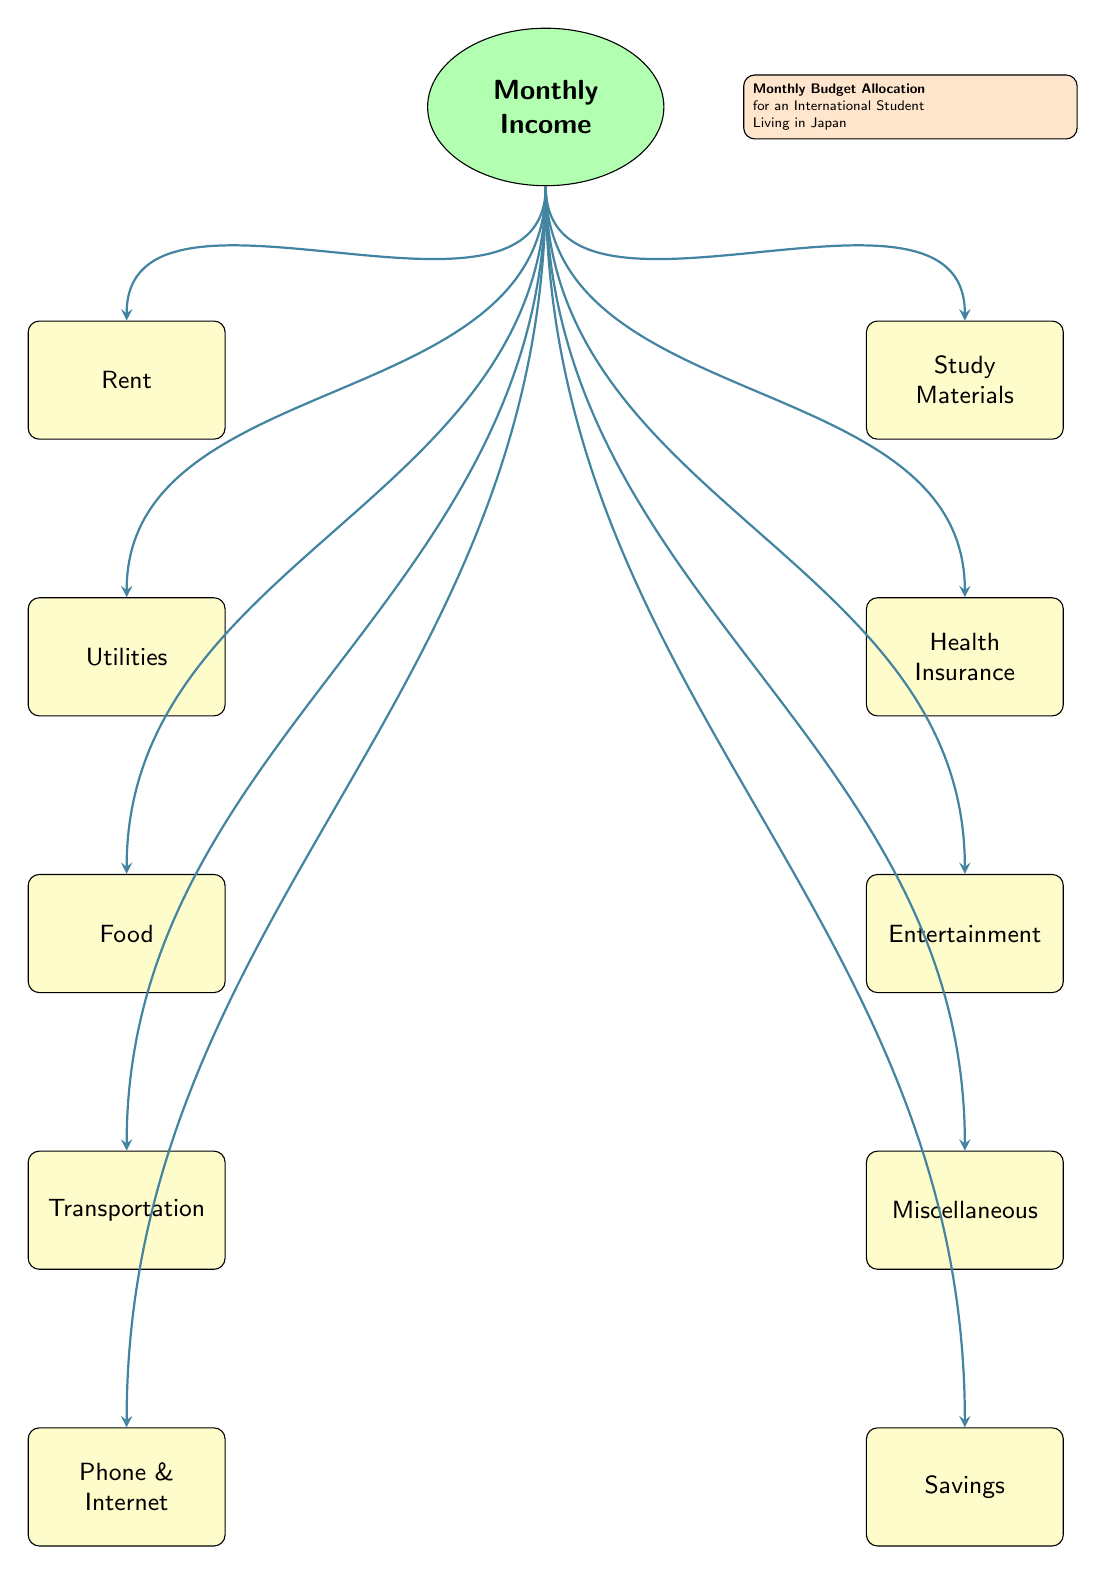What is the first expense node connected to the income? The diagram indicates the first expense directly under the income node, which is rent. This can be identified by observing the direction of the arrows flowing from the income node to each expense node vertically.
Answer: Rent How many total expense nodes are there? By counting all the individual expense nodes listed below the income node, we find there are ten expense categories: Rent, Utilities, Food, Transportation, Phone & Internet, Study Materials, Health Insurance, Entertainment, Miscellaneous, and Savings. Therefore, the total amount of expense nodes is ten.
Answer: 10 What type of shape is used to represent income? The income node is visually represented as an ellipse. We can identify this by looking at the shape classification provided in the diagram's code, where it defines income with a specific drawing style that forms an ellipse.
Answer: Ellipse Which expense node is closest to the income in the top left section? The nearest expense node to the income in the top left section is Rent. We determine this by noting which node appears immediately below the income node on the left side.
Answer: Rent What is the last expense node listed in the right section? The last expense node listed in the right section is Savings. To find this, we follow the sequence of nodes downward in the right area, and Savings appears at the bottom-most position.
Answer: Savings Which two expense categories are directly connected to the health insurance node? The two expense categories directly connected to the health insurance node are Study Materials and Entertainment. This is evident because these two nodes are positioned above and below the health insurance node respectively, following the direction of the arrows.
Answer: Study Materials and Entertainment What color represents the expenses in the diagram? The expense nodes are filled with a yellow color. This is mentioned in the style definition of the expense nodes, which states that they use a yellow fill to distinguish them from the income node.
Answer: Yellow How many nodes are there in the left section of the diagram? In the left section of the diagram, there are five nodes: Rent, Utilities, Food, Transportation, and Phone & Internet. By counting each node in this section, we verify the total number for that area.
Answer: 5 What is the main purpose of the diagram? The diagram's main purpose is to illustrate the Monthly Budget Allocation for an International Student Living in Japan. This can be inferred from the legend on the right side, which summarizes the overall theme and context of the diagram.
Answer: Monthly Budget Allocation 